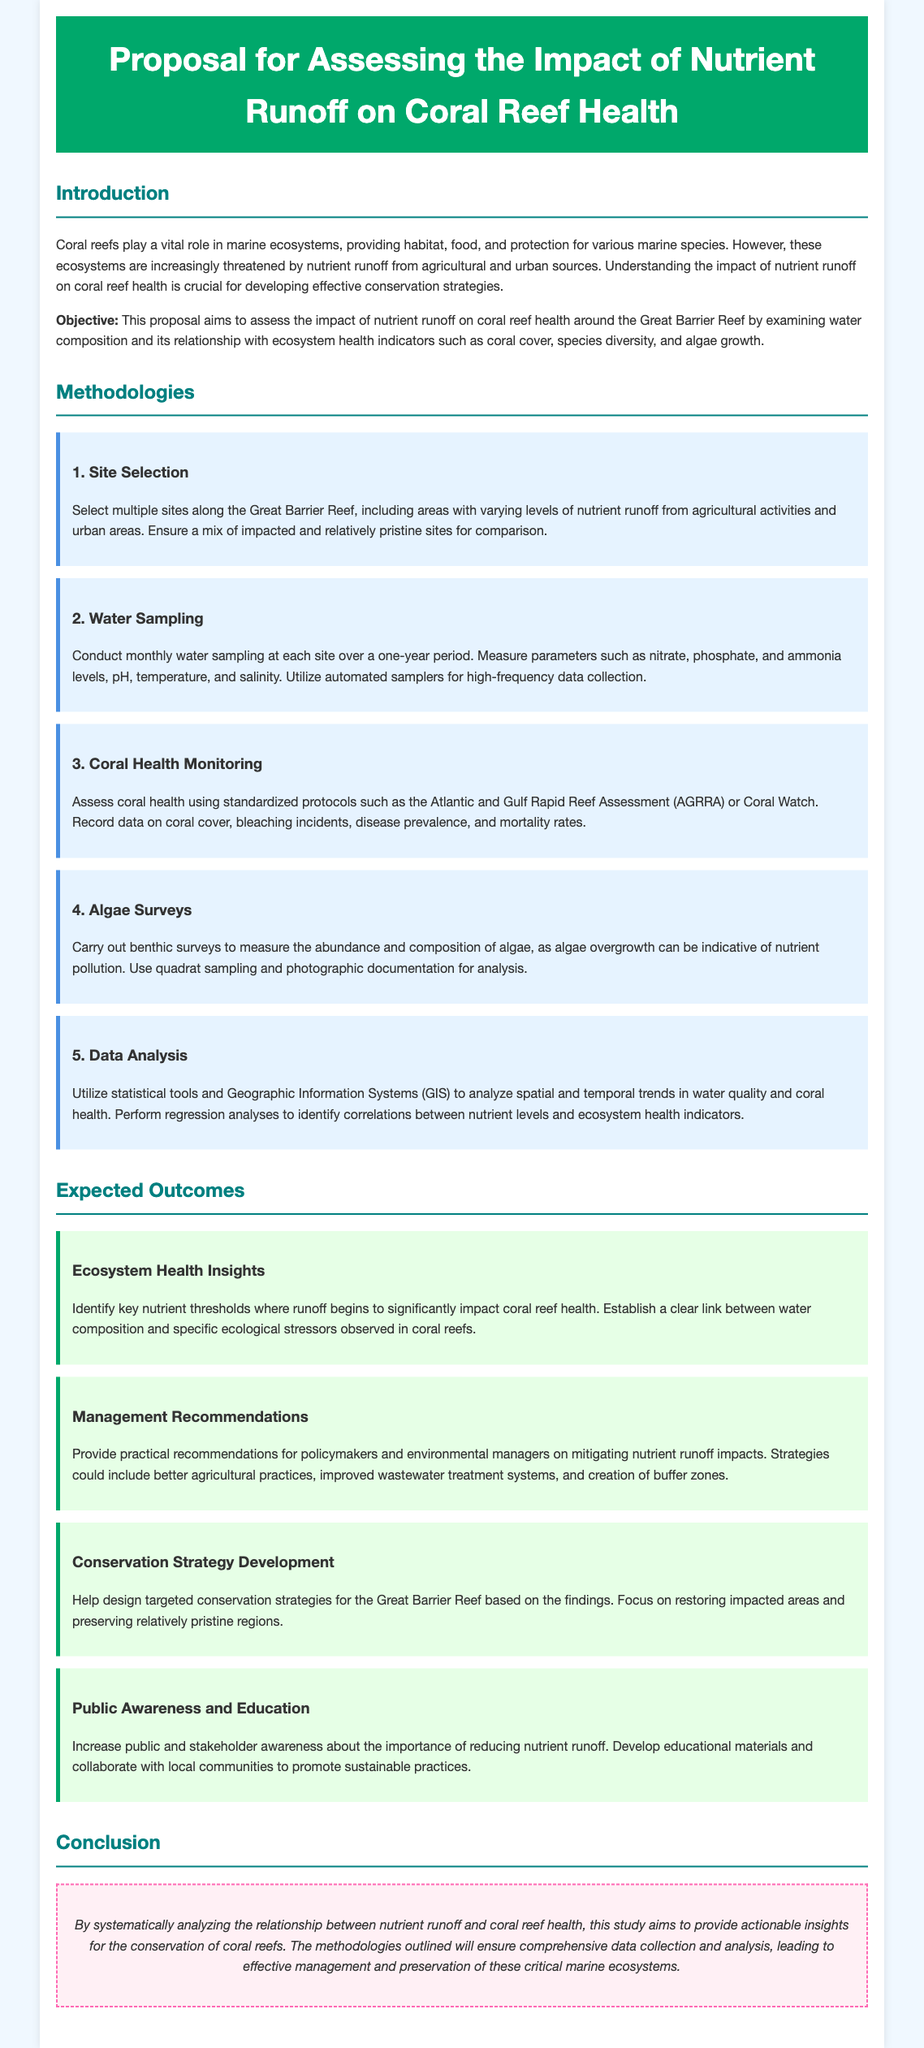what is the title of the proposal? The title of the proposal is found in the header of the document, which states the focus of the project.
Answer: Proposal for Assessing the Impact of Nutrient Runoff on Coral Reef Health what is the objective of the proposal? The objective is stated in the introduction section of the document, outlining the aim of the research performed.
Answer: To assess the impact of nutrient runoff on coral reef health around the Great Barrier Reef how many methodologies are outlined in the proposal? The number of methodologies can be counted in the methodologies section, which lists distinct approaches.
Answer: Five what is the first methodology mentioned? The first methodology is identified at the beginning of the methodologies section, indicating the order of the approaches.
Answer: Site Selection which nutrient levels are measured in the water sampling? The specific parameters listed help identify the focal points of measurement during water sampling.
Answer: Nitrate, phosphate, and ammonia levels what year will the water sampling occur over? The duration for water sampling is specified in the methodologies section, indicating the timeline for data collection.
Answer: One year what is one expected outcome related to ecosystem health insights? The expected outcomes give insights into specific environmental thresholds as discussed in the expected outcomes section.
Answer: Identify key nutrient thresholds where runoff begins to significantly impact coral reef health who are the target audiences for the recommendations provided? The proposal indicates the groups that the management recommendations are intended for, as found in the expected outcomes section.
Answer: Policymakers and environmental managers 